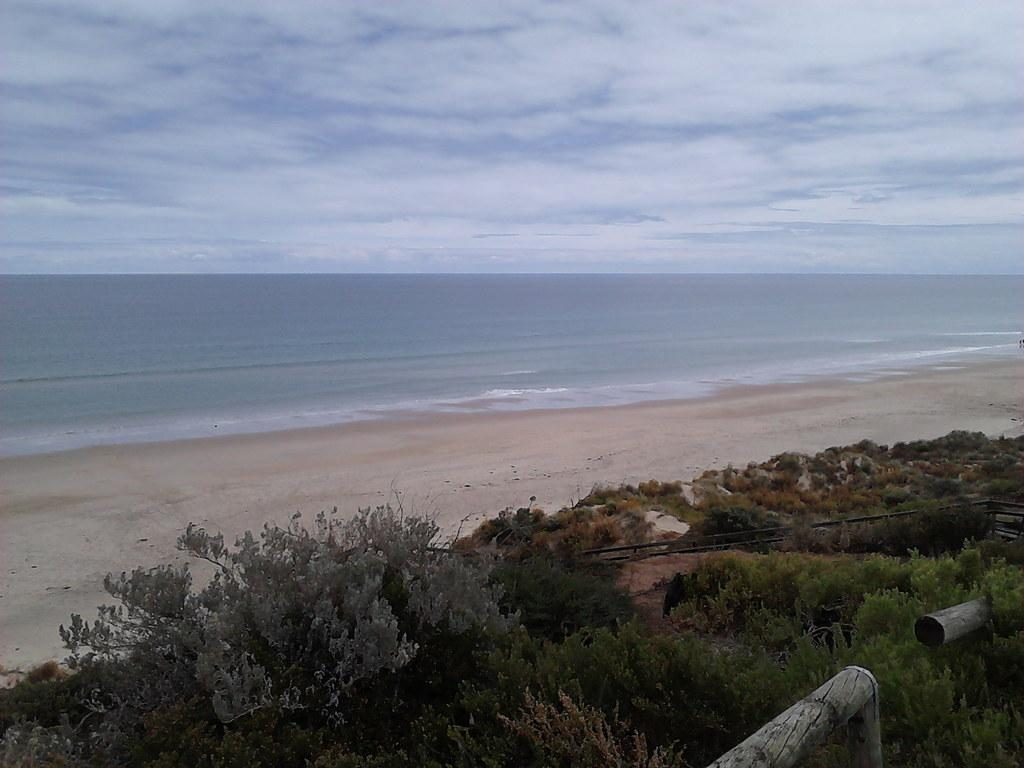What type of natural environment is depicted in the image? The image contains a beach. What type of vegetation can be seen in the image? There is grass and plants present in the image. What kind of structure is visible in the image? There is a wooden pole in the image. What is the weather like in the image? The sky is cloudy in the image. What type of approval is being given by the toes in the image? There are no toes present in the image, so no approval can be given. 